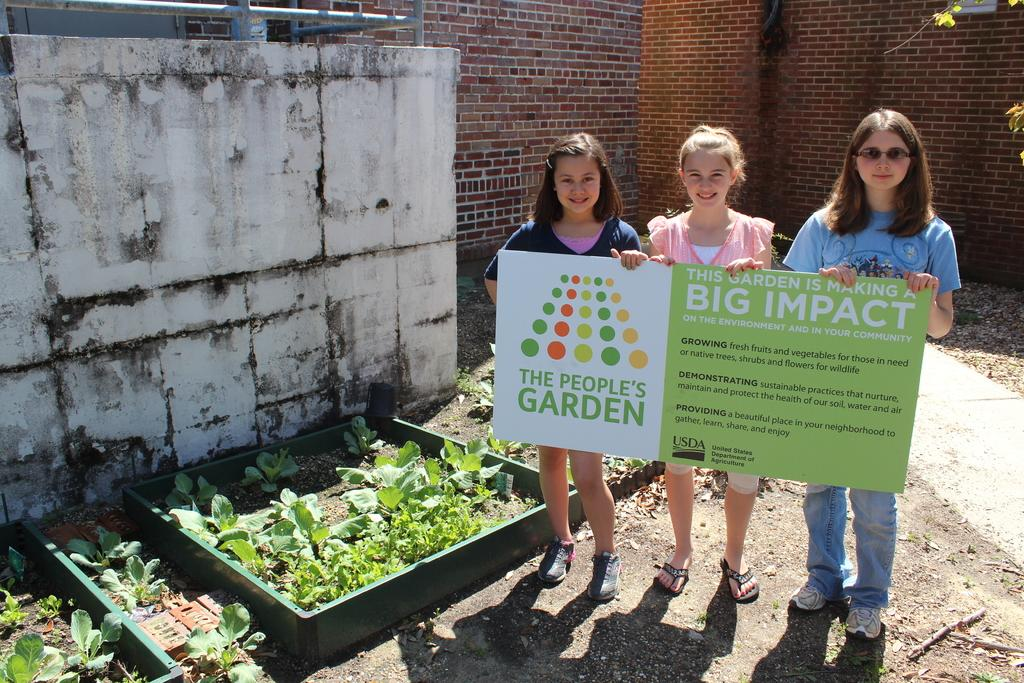How many girls are present in the image? There are three girls in the image. What are the girls holding in the image? The girls are holding a board. What can be seen in the background of the image? There is a building in the background of the image. What type of vegetation is present on the ground in the image? There are plants on the ground in the image. Is there a ship visible in the image? No, there is no ship present in the image. Does the existence of the girls in the image prove the existence of aliens? No, the presence of the girls in the image does not prove the existence of aliens. 